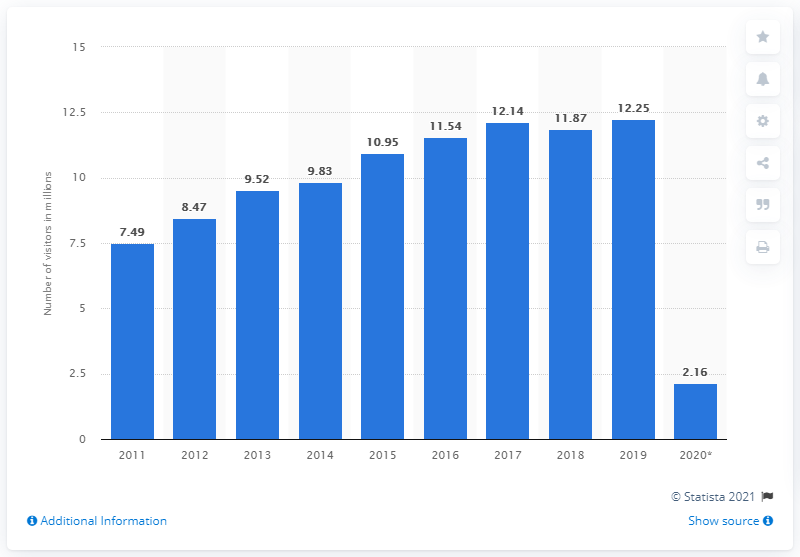Draw attention to some important aspects in this diagram. In 2020, there were 2,160,000 Asian travelers who visited the United States. In 2019, COVID-19 pandemic affected approximately 12.25 million visitors from Asia to the United States. 